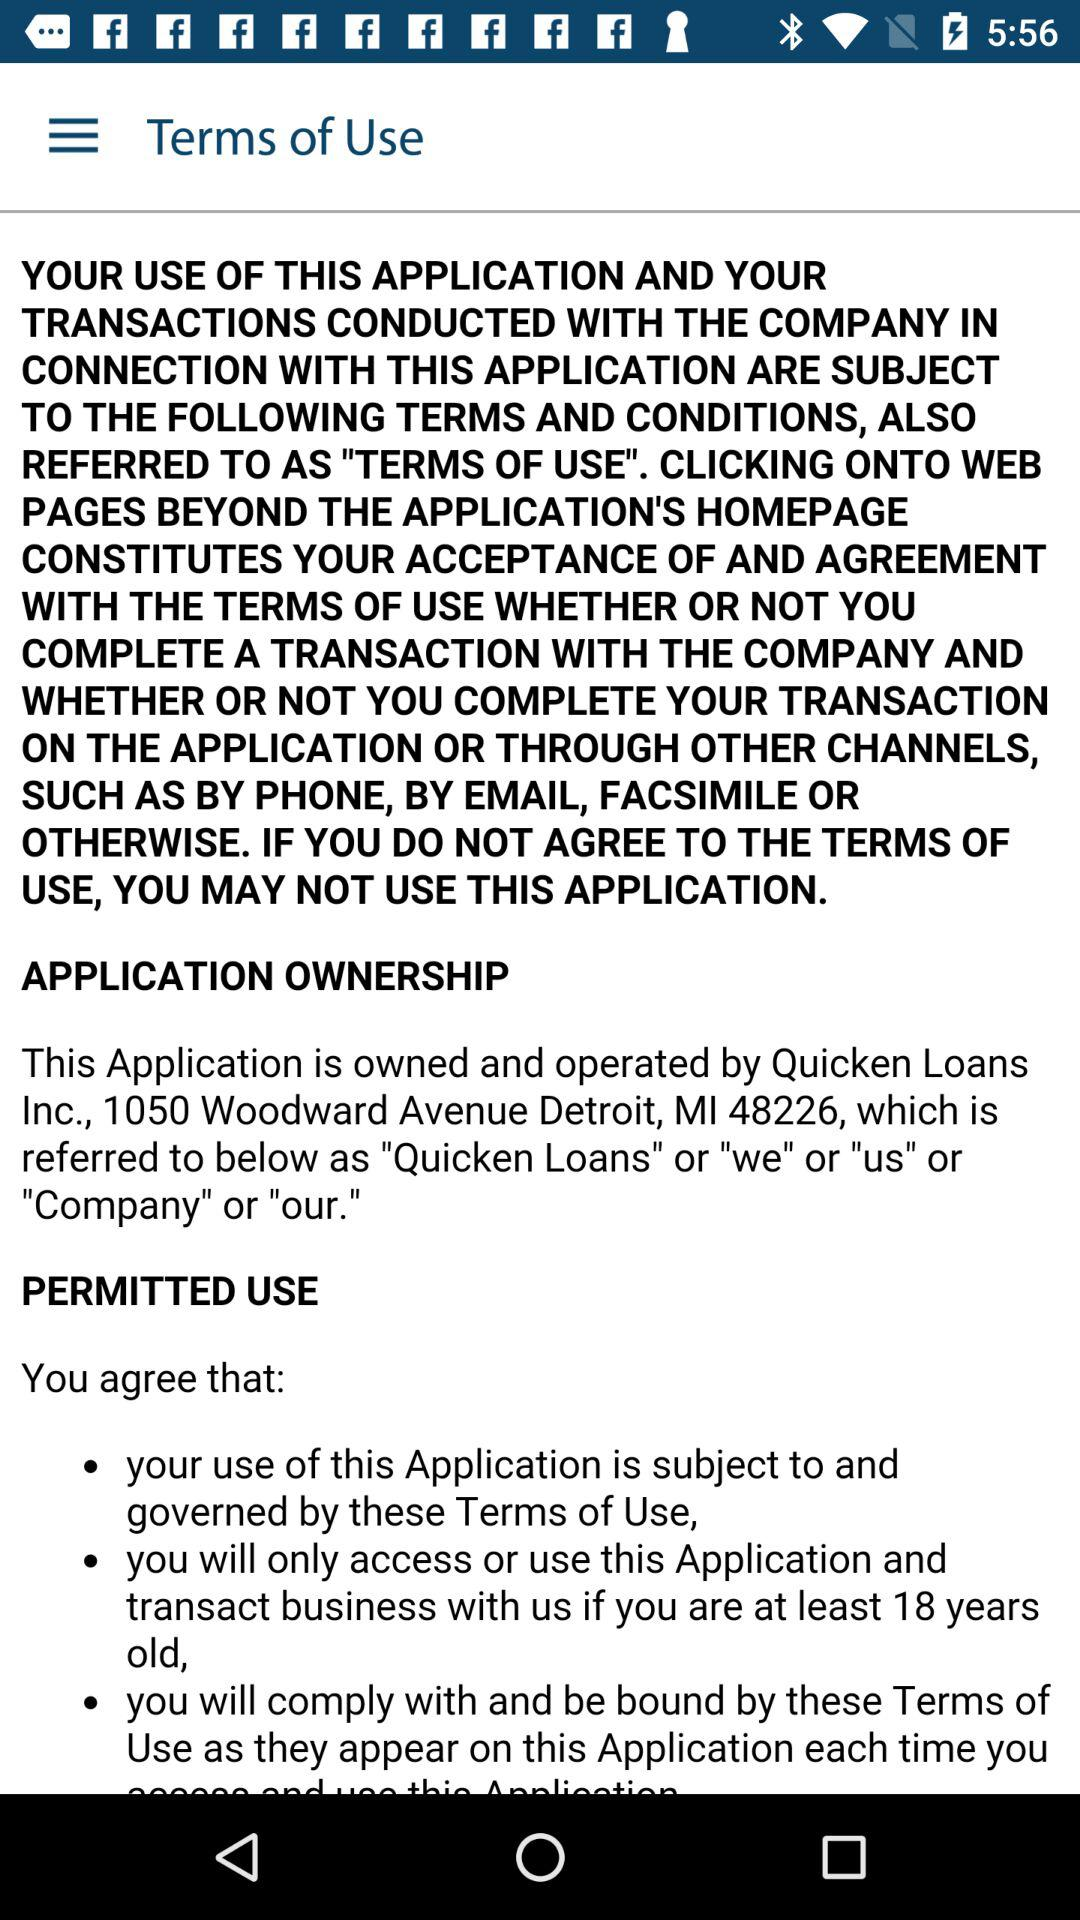Has the user agreed to the terms of use?
When the provided information is insufficient, respond with <no answer>. <no answer> 